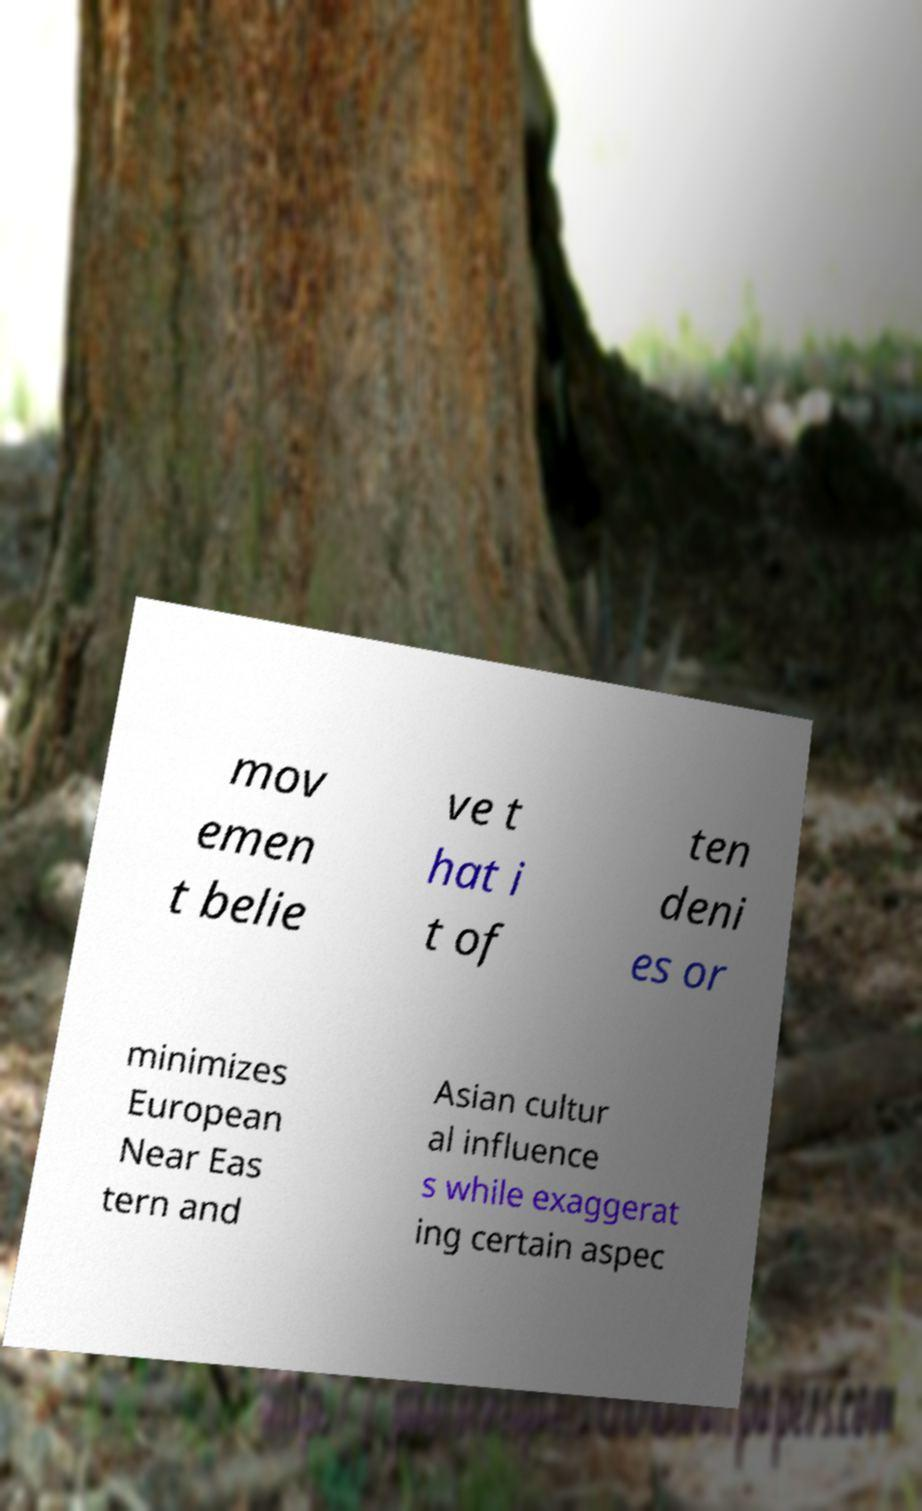I need the written content from this picture converted into text. Can you do that? mov emen t belie ve t hat i t of ten deni es or minimizes European Near Eas tern and Asian cultur al influence s while exaggerat ing certain aspec 